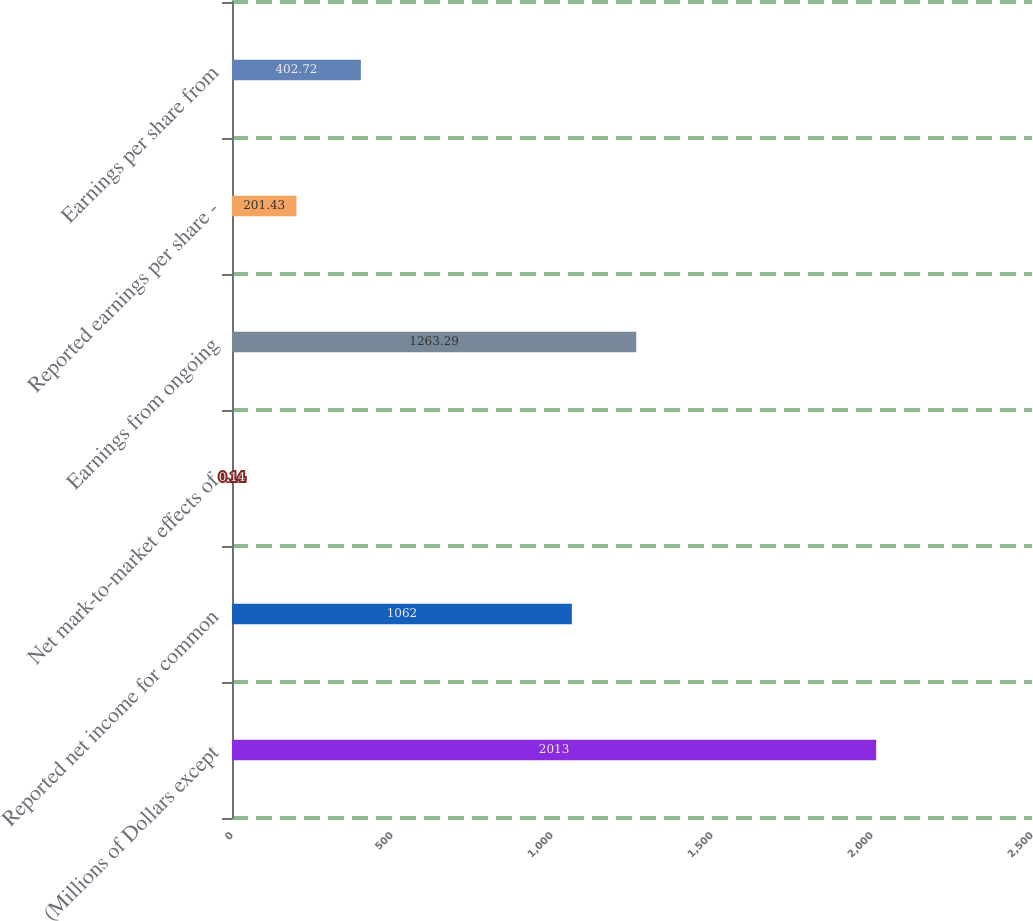Convert chart. <chart><loc_0><loc_0><loc_500><loc_500><bar_chart><fcel>(Millions of Dollars except<fcel>Reported net income for common<fcel>Net mark-to-market effects of<fcel>Earnings from ongoing<fcel>Reported earnings per share -<fcel>Earnings per share from<nl><fcel>2013<fcel>1062<fcel>0.14<fcel>1263.29<fcel>201.43<fcel>402.72<nl></chart> 